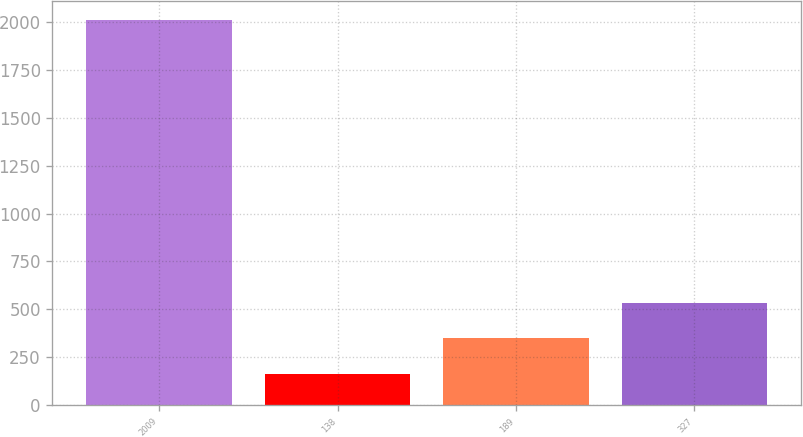Convert chart to OTSL. <chart><loc_0><loc_0><loc_500><loc_500><bar_chart><fcel>2009<fcel>138<fcel>189<fcel>327<nl><fcel>2010<fcel>164<fcel>348.6<fcel>533.2<nl></chart> 